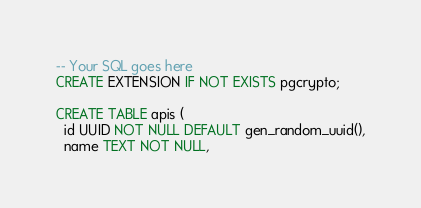Convert code to text. <code><loc_0><loc_0><loc_500><loc_500><_SQL_>-- Your SQL goes here
CREATE EXTENSION IF NOT EXISTS pgcrypto;

CREATE TABLE apis (
  id UUID NOT NULL DEFAULT gen_random_uuid(),
  name TEXT NOT NULL,</code> 